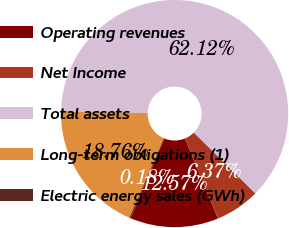Convert chart. <chart><loc_0><loc_0><loc_500><loc_500><pie_chart><fcel>Operating revenues<fcel>Net Income<fcel>Total assets<fcel>Long-term obligations (1)<fcel>Electric energy sales (GWh)<nl><fcel>12.57%<fcel>6.37%<fcel>62.12%<fcel>18.76%<fcel>0.18%<nl></chart> 